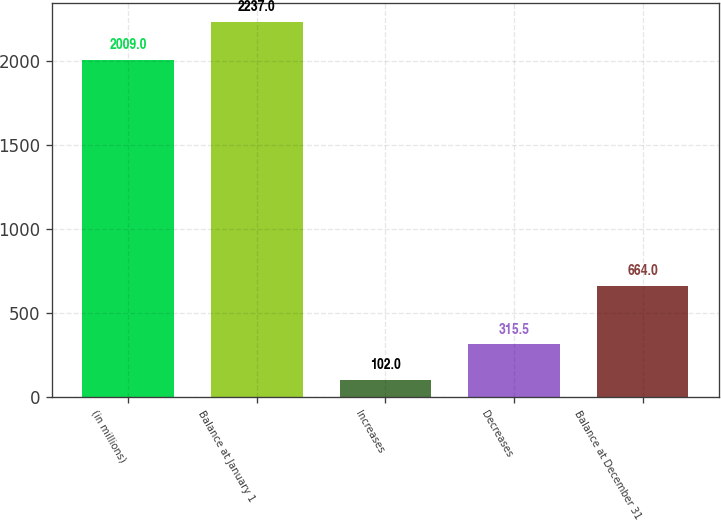<chart> <loc_0><loc_0><loc_500><loc_500><bar_chart><fcel>(in millions)<fcel>Balance at January 1<fcel>Increases<fcel>Decreases<fcel>Balance at December 31<nl><fcel>2009<fcel>2237<fcel>102<fcel>315.5<fcel>664<nl></chart> 